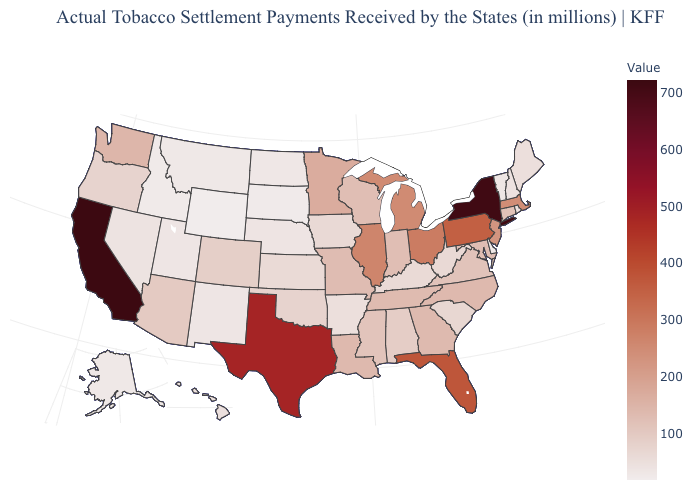Which states have the lowest value in the USA?
Give a very brief answer. Wyoming. Which states have the lowest value in the Northeast?
Short answer required. Vermont. 